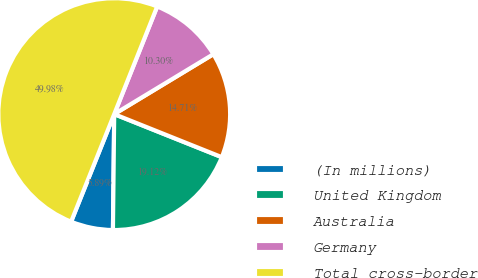Convert chart. <chart><loc_0><loc_0><loc_500><loc_500><pie_chart><fcel>(In millions)<fcel>United Kingdom<fcel>Australia<fcel>Germany<fcel>Total cross-border<nl><fcel>5.89%<fcel>19.12%<fcel>14.71%<fcel>10.3%<fcel>49.98%<nl></chart> 